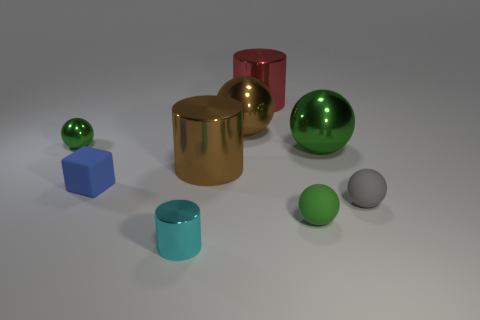Subtract all red cylinders. How many green balls are left? 3 Subtract all small shiny balls. How many balls are left? 4 Subtract all brown balls. How many balls are left? 4 Subtract all blue balls. Subtract all yellow cylinders. How many balls are left? 5 Subtract 1 gray spheres. How many objects are left? 8 Subtract all cubes. How many objects are left? 8 Subtract all big gray metal cubes. Subtract all big brown balls. How many objects are left? 8 Add 9 big green shiny balls. How many big green shiny balls are left? 10 Add 2 big green balls. How many big green balls exist? 3 